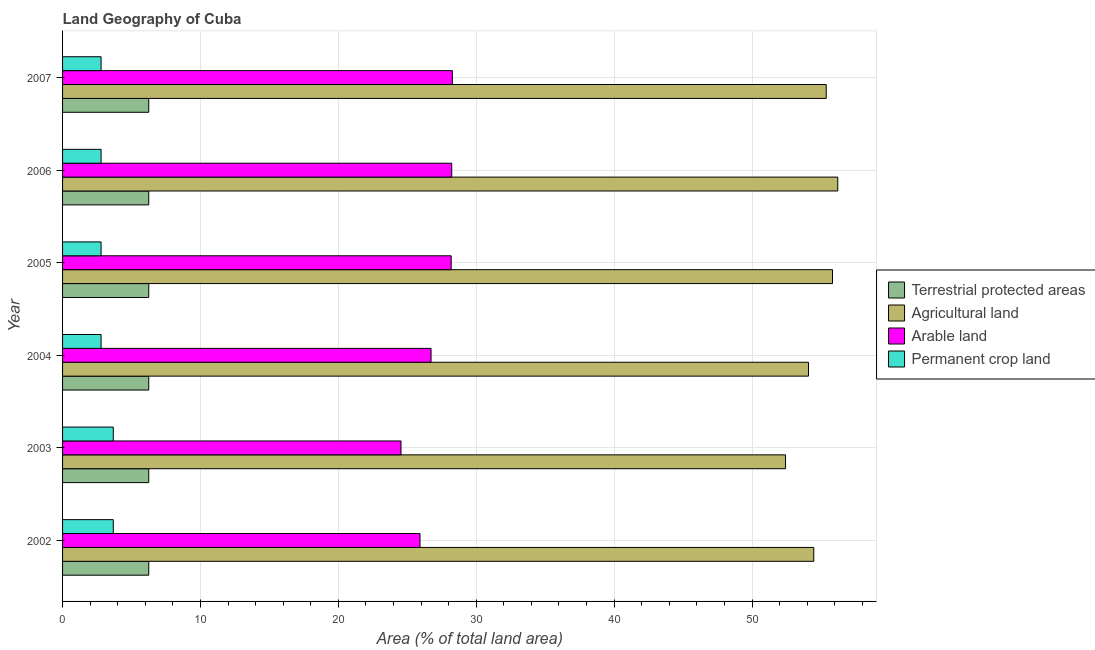How many groups of bars are there?
Offer a very short reply. 6. Are the number of bars per tick equal to the number of legend labels?
Keep it short and to the point. Yes. How many bars are there on the 3rd tick from the bottom?
Your answer should be very brief. 4. What is the label of the 6th group of bars from the top?
Give a very brief answer. 2002. What is the percentage of area under permanent crop land in 2003?
Provide a succinct answer. 3.68. Across all years, what is the maximum percentage of area under agricultural land?
Give a very brief answer. 56.22. Across all years, what is the minimum percentage of land under terrestrial protection?
Keep it short and to the point. 6.25. What is the total percentage of land under terrestrial protection in the graph?
Your response must be concise. 37.5. What is the difference between the percentage of land under terrestrial protection in 2004 and the percentage of area under permanent crop land in 2005?
Your response must be concise. 3.46. What is the average percentage of area under agricultural land per year?
Offer a terse response. 54.74. In the year 2006, what is the difference between the percentage of area under arable land and percentage of area under agricultural land?
Offer a terse response. -28. In how many years, is the percentage of area under agricultural land greater than 54 %?
Ensure brevity in your answer.  5. Is the difference between the percentage of land under terrestrial protection in 2002 and 2004 greater than the difference between the percentage of area under agricultural land in 2002 and 2004?
Your answer should be compact. No. What is the difference between the highest and the second highest percentage of area under permanent crop land?
Offer a terse response. 0. What is the difference between the highest and the lowest percentage of area under agricultural land?
Ensure brevity in your answer.  3.79. Is the sum of the percentage of area under agricultural land in 2002 and 2004 greater than the maximum percentage of land under terrestrial protection across all years?
Offer a very short reply. Yes. Is it the case that in every year, the sum of the percentage of area under permanent crop land and percentage of area under arable land is greater than the sum of percentage of area under agricultural land and percentage of land under terrestrial protection?
Provide a succinct answer. No. What does the 1st bar from the top in 2002 represents?
Your answer should be compact. Permanent crop land. What does the 1st bar from the bottom in 2004 represents?
Make the answer very short. Terrestrial protected areas. Is it the case that in every year, the sum of the percentage of land under terrestrial protection and percentage of area under agricultural land is greater than the percentage of area under arable land?
Give a very brief answer. Yes. Are the values on the major ticks of X-axis written in scientific E-notation?
Make the answer very short. No. Where does the legend appear in the graph?
Your response must be concise. Center right. What is the title of the graph?
Offer a terse response. Land Geography of Cuba. What is the label or title of the X-axis?
Provide a succinct answer. Area (% of total land area). What is the label or title of the Y-axis?
Offer a terse response. Year. What is the Area (% of total land area) of Terrestrial protected areas in 2002?
Provide a short and direct response. 6.25. What is the Area (% of total land area) of Agricultural land in 2002?
Ensure brevity in your answer.  54.48. What is the Area (% of total land area) in Arable land in 2002?
Provide a short and direct response. 25.92. What is the Area (% of total land area) of Permanent crop land in 2002?
Make the answer very short. 3.68. What is the Area (% of total land area) of Terrestrial protected areas in 2003?
Give a very brief answer. 6.25. What is the Area (% of total land area) in Agricultural land in 2003?
Provide a short and direct response. 52.43. What is the Area (% of total land area) in Arable land in 2003?
Give a very brief answer. 24.54. What is the Area (% of total land area) in Permanent crop land in 2003?
Make the answer very short. 3.68. What is the Area (% of total land area) of Terrestrial protected areas in 2004?
Provide a succinct answer. 6.25. What is the Area (% of total land area) in Agricultural land in 2004?
Your answer should be compact. 54.1. What is the Area (% of total land area) in Arable land in 2004?
Give a very brief answer. 26.72. What is the Area (% of total land area) of Permanent crop land in 2004?
Your answer should be compact. 2.79. What is the Area (% of total land area) of Terrestrial protected areas in 2005?
Provide a succinct answer. 6.25. What is the Area (% of total land area) of Agricultural land in 2005?
Ensure brevity in your answer.  55.84. What is the Area (% of total land area) of Arable land in 2005?
Give a very brief answer. 28.18. What is the Area (% of total land area) in Permanent crop land in 2005?
Keep it short and to the point. 2.79. What is the Area (% of total land area) in Terrestrial protected areas in 2006?
Keep it short and to the point. 6.25. What is the Area (% of total land area) in Agricultural land in 2006?
Ensure brevity in your answer.  56.22. What is the Area (% of total land area) of Arable land in 2006?
Offer a very short reply. 28.22. What is the Area (% of total land area) of Permanent crop land in 2006?
Offer a very short reply. 2.79. What is the Area (% of total land area) of Terrestrial protected areas in 2007?
Your answer should be very brief. 6.25. What is the Area (% of total land area) in Agricultural land in 2007?
Provide a short and direct response. 55.38. What is the Area (% of total land area) of Arable land in 2007?
Keep it short and to the point. 28.27. What is the Area (% of total land area) of Permanent crop land in 2007?
Offer a terse response. 2.79. Across all years, what is the maximum Area (% of total land area) in Terrestrial protected areas?
Offer a very short reply. 6.25. Across all years, what is the maximum Area (% of total land area) in Agricultural land?
Offer a terse response. 56.22. Across all years, what is the maximum Area (% of total land area) in Arable land?
Keep it short and to the point. 28.27. Across all years, what is the maximum Area (% of total land area) in Permanent crop land?
Offer a terse response. 3.68. Across all years, what is the minimum Area (% of total land area) in Terrestrial protected areas?
Offer a very short reply. 6.25. Across all years, what is the minimum Area (% of total land area) in Agricultural land?
Give a very brief answer. 52.43. Across all years, what is the minimum Area (% of total land area) in Arable land?
Your answer should be compact. 24.54. Across all years, what is the minimum Area (% of total land area) of Permanent crop land?
Offer a very short reply. 2.79. What is the total Area (% of total land area) in Terrestrial protected areas in the graph?
Ensure brevity in your answer.  37.5. What is the total Area (% of total land area) in Agricultural land in the graph?
Make the answer very short. 328.45. What is the total Area (% of total land area) in Arable land in the graph?
Offer a very short reply. 161.86. What is the total Area (% of total land area) of Permanent crop land in the graph?
Keep it short and to the point. 18.53. What is the difference between the Area (% of total land area) of Agricultural land in 2002 and that in 2003?
Provide a short and direct response. 2.05. What is the difference between the Area (% of total land area) of Arable land in 2002 and that in 2003?
Your answer should be compact. 1.38. What is the difference between the Area (% of total land area) in Permanent crop land in 2002 and that in 2003?
Provide a succinct answer. 0. What is the difference between the Area (% of total land area) in Agricultural land in 2002 and that in 2004?
Provide a short and direct response. 0.38. What is the difference between the Area (% of total land area) in Arable land in 2002 and that in 2004?
Keep it short and to the point. -0.8. What is the difference between the Area (% of total land area) in Permanent crop land in 2002 and that in 2004?
Make the answer very short. 0.88. What is the difference between the Area (% of total land area) in Terrestrial protected areas in 2002 and that in 2005?
Your answer should be very brief. 0. What is the difference between the Area (% of total land area) of Agricultural land in 2002 and that in 2005?
Your answer should be very brief. -1.36. What is the difference between the Area (% of total land area) of Arable land in 2002 and that in 2005?
Provide a succinct answer. -2.26. What is the difference between the Area (% of total land area) of Permanent crop land in 2002 and that in 2005?
Provide a succinct answer. 0.88. What is the difference between the Area (% of total land area) in Terrestrial protected areas in 2002 and that in 2006?
Keep it short and to the point. 0. What is the difference between the Area (% of total land area) in Agricultural land in 2002 and that in 2006?
Your answer should be compact. -1.74. What is the difference between the Area (% of total land area) of Arable land in 2002 and that in 2006?
Provide a short and direct response. -2.3. What is the difference between the Area (% of total land area) in Permanent crop land in 2002 and that in 2006?
Your answer should be very brief. 0.88. What is the difference between the Area (% of total land area) in Agricultural land in 2002 and that in 2007?
Give a very brief answer. -0.9. What is the difference between the Area (% of total land area) in Arable land in 2002 and that in 2007?
Give a very brief answer. -2.35. What is the difference between the Area (% of total land area) in Permanent crop land in 2002 and that in 2007?
Give a very brief answer. 0.88. What is the difference between the Area (% of total land area) in Agricultural land in 2003 and that in 2004?
Offer a very short reply. -1.67. What is the difference between the Area (% of total land area) in Arable land in 2003 and that in 2004?
Give a very brief answer. -2.18. What is the difference between the Area (% of total land area) of Permanent crop land in 2003 and that in 2004?
Your answer should be compact. 0.88. What is the difference between the Area (% of total land area) of Agricultural land in 2003 and that in 2005?
Offer a very short reply. -3.41. What is the difference between the Area (% of total land area) of Arable land in 2003 and that in 2005?
Keep it short and to the point. -3.64. What is the difference between the Area (% of total land area) in Permanent crop land in 2003 and that in 2005?
Offer a terse response. 0.88. What is the difference between the Area (% of total land area) of Terrestrial protected areas in 2003 and that in 2006?
Provide a short and direct response. 0. What is the difference between the Area (% of total land area) in Agricultural land in 2003 and that in 2006?
Ensure brevity in your answer.  -3.79. What is the difference between the Area (% of total land area) in Arable land in 2003 and that in 2006?
Your answer should be compact. -3.68. What is the difference between the Area (% of total land area) of Permanent crop land in 2003 and that in 2006?
Give a very brief answer. 0.88. What is the difference between the Area (% of total land area) in Terrestrial protected areas in 2003 and that in 2007?
Ensure brevity in your answer.  0. What is the difference between the Area (% of total land area) of Agricultural land in 2003 and that in 2007?
Ensure brevity in your answer.  -2.95. What is the difference between the Area (% of total land area) in Arable land in 2003 and that in 2007?
Offer a very short reply. -3.72. What is the difference between the Area (% of total land area) of Permanent crop land in 2003 and that in 2007?
Offer a very short reply. 0.88. What is the difference between the Area (% of total land area) of Agricultural land in 2004 and that in 2005?
Offer a terse response. -1.74. What is the difference between the Area (% of total land area) of Arable land in 2004 and that in 2005?
Give a very brief answer. -1.46. What is the difference between the Area (% of total land area) of Terrestrial protected areas in 2004 and that in 2006?
Your response must be concise. 0. What is the difference between the Area (% of total land area) in Agricultural land in 2004 and that in 2006?
Your answer should be compact. -2.12. What is the difference between the Area (% of total land area) of Arable land in 2004 and that in 2006?
Your answer should be very brief. -1.5. What is the difference between the Area (% of total land area) in Permanent crop land in 2004 and that in 2006?
Provide a short and direct response. 0. What is the difference between the Area (% of total land area) of Agricultural land in 2004 and that in 2007?
Provide a succinct answer. -1.28. What is the difference between the Area (% of total land area) in Arable land in 2004 and that in 2007?
Offer a terse response. -1.55. What is the difference between the Area (% of total land area) in Permanent crop land in 2004 and that in 2007?
Give a very brief answer. 0. What is the difference between the Area (% of total land area) of Agricultural land in 2005 and that in 2006?
Offer a terse response. -0.38. What is the difference between the Area (% of total land area) of Arable land in 2005 and that in 2006?
Offer a terse response. -0.04. What is the difference between the Area (% of total land area) of Permanent crop land in 2005 and that in 2006?
Provide a short and direct response. 0. What is the difference between the Area (% of total land area) in Agricultural land in 2005 and that in 2007?
Offer a terse response. 0.46. What is the difference between the Area (% of total land area) of Arable land in 2005 and that in 2007?
Make the answer very short. -0.08. What is the difference between the Area (% of total land area) in Permanent crop land in 2005 and that in 2007?
Offer a terse response. 0. What is the difference between the Area (% of total land area) in Agricultural land in 2006 and that in 2007?
Make the answer very short. 0.84. What is the difference between the Area (% of total land area) of Arable land in 2006 and that in 2007?
Your answer should be compact. -0.05. What is the difference between the Area (% of total land area) of Terrestrial protected areas in 2002 and the Area (% of total land area) of Agricultural land in 2003?
Your response must be concise. -46.18. What is the difference between the Area (% of total land area) in Terrestrial protected areas in 2002 and the Area (% of total land area) in Arable land in 2003?
Provide a succinct answer. -18.29. What is the difference between the Area (% of total land area) in Terrestrial protected areas in 2002 and the Area (% of total land area) in Permanent crop land in 2003?
Provide a short and direct response. 2.57. What is the difference between the Area (% of total land area) of Agricultural land in 2002 and the Area (% of total land area) of Arable land in 2003?
Provide a succinct answer. 29.93. What is the difference between the Area (% of total land area) of Agricultural land in 2002 and the Area (% of total land area) of Permanent crop land in 2003?
Give a very brief answer. 50.8. What is the difference between the Area (% of total land area) of Arable land in 2002 and the Area (% of total land area) of Permanent crop land in 2003?
Offer a very short reply. 22.24. What is the difference between the Area (% of total land area) in Terrestrial protected areas in 2002 and the Area (% of total land area) in Agricultural land in 2004?
Make the answer very short. -47.85. What is the difference between the Area (% of total land area) of Terrestrial protected areas in 2002 and the Area (% of total land area) of Arable land in 2004?
Provide a short and direct response. -20.47. What is the difference between the Area (% of total land area) of Terrestrial protected areas in 2002 and the Area (% of total land area) of Permanent crop land in 2004?
Offer a terse response. 3.46. What is the difference between the Area (% of total land area) of Agricultural land in 2002 and the Area (% of total land area) of Arable land in 2004?
Offer a terse response. 27.76. What is the difference between the Area (% of total land area) in Agricultural land in 2002 and the Area (% of total land area) in Permanent crop land in 2004?
Make the answer very short. 51.69. What is the difference between the Area (% of total land area) in Arable land in 2002 and the Area (% of total land area) in Permanent crop land in 2004?
Offer a very short reply. 23.13. What is the difference between the Area (% of total land area) of Terrestrial protected areas in 2002 and the Area (% of total land area) of Agricultural land in 2005?
Provide a short and direct response. -49.59. What is the difference between the Area (% of total land area) in Terrestrial protected areas in 2002 and the Area (% of total land area) in Arable land in 2005?
Provide a short and direct response. -21.93. What is the difference between the Area (% of total land area) of Terrestrial protected areas in 2002 and the Area (% of total land area) of Permanent crop land in 2005?
Provide a short and direct response. 3.46. What is the difference between the Area (% of total land area) in Agricultural land in 2002 and the Area (% of total land area) in Arable land in 2005?
Give a very brief answer. 26.29. What is the difference between the Area (% of total land area) of Agricultural land in 2002 and the Area (% of total land area) of Permanent crop land in 2005?
Offer a terse response. 51.69. What is the difference between the Area (% of total land area) of Arable land in 2002 and the Area (% of total land area) of Permanent crop land in 2005?
Offer a terse response. 23.13. What is the difference between the Area (% of total land area) of Terrestrial protected areas in 2002 and the Area (% of total land area) of Agricultural land in 2006?
Give a very brief answer. -49.97. What is the difference between the Area (% of total land area) of Terrestrial protected areas in 2002 and the Area (% of total land area) of Arable land in 2006?
Your response must be concise. -21.97. What is the difference between the Area (% of total land area) in Terrestrial protected areas in 2002 and the Area (% of total land area) in Permanent crop land in 2006?
Your response must be concise. 3.46. What is the difference between the Area (% of total land area) in Agricultural land in 2002 and the Area (% of total land area) in Arable land in 2006?
Your response must be concise. 26.26. What is the difference between the Area (% of total land area) of Agricultural land in 2002 and the Area (% of total land area) of Permanent crop land in 2006?
Provide a succinct answer. 51.69. What is the difference between the Area (% of total land area) in Arable land in 2002 and the Area (% of total land area) in Permanent crop land in 2006?
Offer a terse response. 23.13. What is the difference between the Area (% of total land area) of Terrestrial protected areas in 2002 and the Area (% of total land area) of Agricultural land in 2007?
Offer a terse response. -49.13. What is the difference between the Area (% of total land area) in Terrestrial protected areas in 2002 and the Area (% of total land area) in Arable land in 2007?
Your answer should be compact. -22.02. What is the difference between the Area (% of total land area) of Terrestrial protected areas in 2002 and the Area (% of total land area) of Permanent crop land in 2007?
Offer a very short reply. 3.46. What is the difference between the Area (% of total land area) in Agricultural land in 2002 and the Area (% of total land area) in Arable land in 2007?
Your response must be concise. 26.21. What is the difference between the Area (% of total land area) in Agricultural land in 2002 and the Area (% of total land area) in Permanent crop land in 2007?
Offer a very short reply. 51.69. What is the difference between the Area (% of total land area) in Arable land in 2002 and the Area (% of total land area) in Permanent crop land in 2007?
Ensure brevity in your answer.  23.13. What is the difference between the Area (% of total land area) in Terrestrial protected areas in 2003 and the Area (% of total land area) in Agricultural land in 2004?
Give a very brief answer. -47.85. What is the difference between the Area (% of total land area) of Terrestrial protected areas in 2003 and the Area (% of total land area) of Arable land in 2004?
Give a very brief answer. -20.47. What is the difference between the Area (% of total land area) in Terrestrial protected areas in 2003 and the Area (% of total land area) in Permanent crop land in 2004?
Make the answer very short. 3.46. What is the difference between the Area (% of total land area) of Agricultural land in 2003 and the Area (% of total land area) of Arable land in 2004?
Offer a very short reply. 25.71. What is the difference between the Area (% of total land area) in Agricultural land in 2003 and the Area (% of total land area) in Permanent crop land in 2004?
Your response must be concise. 49.64. What is the difference between the Area (% of total land area) of Arable land in 2003 and the Area (% of total land area) of Permanent crop land in 2004?
Provide a succinct answer. 21.75. What is the difference between the Area (% of total land area) of Terrestrial protected areas in 2003 and the Area (% of total land area) of Agricultural land in 2005?
Offer a very short reply. -49.59. What is the difference between the Area (% of total land area) in Terrestrial protected areas in 2003 and the Area (% of total land area) in Arable land in 2005?
Make the answer very short. -21.93. What is the difference between the Area (% of total land area) in Terrestrial protected areas in 2003 and the Area (% of total land area) in Permanent crop land in 2005?
Your answer should be compact. 3.46. What is the difference between the Area (% of total land area) in Agricultural land in 2003 and the Area (% of total land area) in Arable land in 2005?
Give a very brief answer. 24.25. What is the difference between the Area (% of total land area) of Agricultural land in 2003 and the Area (% of total land area) of Permanent crop land in 2005?
Your answer should be very brief. 49.64. What is the difference between the Area (% of total land area) of Arable land in 2003 and the Area (% of total land area) of Permanent crop land in 2005?
Your response must be concise. 21.75. What is the difference between the Area (% of total land area) in Terrestrial protected areas in 2003 and the Area (% of total land area) in Agricultural land in 2006?
Offer a terse response. -49.97. What is the difference between the Area (% of total land area) of Terrestrial protected areas in 2003 and the Area (% of total land area) of Arable land in 2006?
Provide a succinct answer. -21.97. What is the difference between the Area (% of total land area) of Terrestrial protected areas in 2003 and the Area (% of total land area) of Permanent crop land in 2006?
Your answer should be compact. 3.46. What is the difference between the Area (% of total land area) in Agricultural land in 2003 and the Area (% of total land area) in Arable land in 2006?
Provide a succinct answer. 24.21. What is the difference between the Area (% of total land area) of Agricultural land in 2003 and the Area (% of total land area) of Permanent crop land in 2006?
Offer a terse response. 49.64. What is the difference between the Area (% of total land area) of Arable land in 2003 and the Area (% of total land area) of Permanent crop land in 2006?
Provide a short and direct response. 21.75. What is the difference between the Area (% of total land area) in Terrestrial protected areas in 2003 and the Area (% of total land area) in Agricultural land in 2007?
Keep it short and to the point. -49.13. What is the difference between the Area (% of total land area) in Terrestrial protected areas in 2003 and the Area (% of total land area) in Arable land in 2007?
Provide a succinct answer. -22.02. What is the difference between the Area (% of total land area) of Terrestrial protected areas in 2003 and the Area (% of total land area) of Permanent crop land in 2007?
Your response must be concise. 3.46. What is the difference between the Area (% of total land area) of Agricultural land in 2003 and the Area (% of total land area) of Arable land in 2007?
Ensure brevity in your answer.  24.16. What is the difference between the Area (% of total land area) in Agricultural land in 2003 and the Area (% of total land area) in Permanent crop land in 2007?
Your answer should be very brief. 49.64. What is the difference between the Area (% of total land area) in Arable land in 2003 and the Area (% of total land area) in Permanent crop land in 2007?
Give a very brief answer. 21.75. What is the difference between the Area (% of total land area) of Terrestrial protected areas in 2004 and the Area (% of total land area) of Agricultural land in 2005?
Your answer should be compact. -49.59. What is the difference between the Area (% of total land area) in Terrestrial protected areas in 2004 and the Area (% of total land area) in Arable land in 2005?
Give a very brief answer. -21.93. What is the difference between the Area (% of total land area) in Terrestrial protected areas in 2004 and the Area (% of total land area) in Permanent crop land in 2005?
Your response must be concise. 3.46. What is the difference between the Area (% of total land area) in Agricultural land in 2004 and the Area (% of total land area) in Arable land in 2005?
Offer a terse response. 25.91. What is the difference between the Area (% of total land area) of Agricultural land in 2004 and the Area (% of total land area) of Permanent crop land in 2005?
Provide a short and direct response. 51.3. What is the difference between the Area (% of total land area) of Arable land in 2004 and the Area (% of total land area) of Permanent crop land in 2005?
Keep it short and to the point. 23.93. What is the difference between the Area (% of total land area) in Terrestrial protected areas in 2004 and the Area (% of total land area) in Agricultural land in 2006?
Your answer should be compact. -49.97. What is the difference between the Area (% of total land area) in Terrestrial protected areas in 2004 and the Area (% of total land area) in Arable land in 2006?
Your answer should be compact. -21.97. What is the difference between the Area (% of total land area) of Terrestrial protected areas in 2004 and the Area (% of total land area) of Permanent crop land in 2006?
Give a very brief answer. 3.46. What is the difference between the Area (% of total land area) in Agricultural land in 2004 and the Area (% of total land area) in Arable land in 2006?
Make the answer very short. 25.88. What is the difference between the Area (% of total land area) of Agricultural land in 2004 and the Area (% of total land area) of Permanent crop land in 2006?
Your answer should be very brief. 51.3. What is the difference between the Area (% of total land area) in Arable land in 2004 and the Area (% of total land area) in Permanent crop land in 2006?
Offer a very short reply. 23.93. What is the difference between the Area (% of total land area) of Terrestrial protected areas in 2004 and the Area (% of total land area) of Agricultural land in 2007?
Your answer should be compact. -49.13. What is the difference between the Area (% of total land area) of Terrestrial protected areas in 2004 and the Area (% of total land area) of Arable land in 2007?
Provide a short and direct response. -22.02. What is the difference between the Area (% of total land area) of Terrestrial protected areas in 2004 and the Area (% of total land area) of Permanent crop land in 2007?
Your answer should be very brief. 3.46. What is the difference between the Area (% of total land area) of Agricultural land in 2004 and the Area (% of total land area) of Arable land in 2007?
Offer a terse response. 25.83. What is the difference between the Area (% of total land area) of Agricultural land in 2004 and the Area (% of total land area) of Permanent crop land in 2007?
Provide a short and direct response. 51.3. What is the difference between the Area (% of total land area) in Arable land in 2004 and the Area (% of total land area) in Permanent crop land in 2007?
Your answer should be compact. 23.93. What is the difference between the Area (% of total land area) in Terrestrial protected areas in 2005 and the Area (% of total land area) in Agricultural land in 2006?
Make the answer very short. -49.97. What is the difference between the Area (% of total land area) in Terrestrial protected areas in 2005 and the Area (% of total land area) in Arable land in 2006?
Your answer should be compact. -21.97. What is the difference between the Area (% of total land area) in Terrestrial protected areas in 2005 and the Area (% of total land area) in Permanent crop land in 2006?
Offer a terse response. 3.46. What is the difference between the Area (% of total land area) in Agricultural land in 2005 and the Area (% of total land area) in Arable land in 2006?
Make the answer very short. 27.62. What is the difference between the Area (% of total land area) of Agricultural land in 2005 and the Area (% of total land area) of Permanent crop land in 2006?
Offer a very short reply. 53.04. What is the difference between the Area (% of total land area) of Arable land in 2005 and the Area (% of total land area) of Permanent crop land in 2006?
Your response must be concise. 25.39. What is the difference between the Area (% of total land area) in Terrestrial protected areas in 2005 and the Area (% of total land area) in Agricultural land in 2007?
Make the answer very short. -49.13. What is the difference between the Area (% of total land area) in Terrestrial protected areas in 2005 and the Area (% of total land area) in Arable land in 2007?
Your answer should be compact. -22.02. What is the difference between the Area (% of total land area) in Terrestrial protected areas in 2005 and the Area (% of total land area) in Permanent crop land in 2007?
Provide a succinct answer. 3.46. What is the difference between the Area (% of total land area) of Agricultural land in 2005 and the Area (% of total land area) of Arable land in 2007?
Offer a very short reply. 27.57. What is the difference between the Area (% of total land area) in Agricultural land in 2005 and the Area (% of total land area) in Permanent crop land in 2007?
Offer a very short reply. 53.04. What is the difference between the Area (% of total land area) in Arable land in 2005 and the Area (% of total land area) in Permanent crop land in 2007?
Your answer should be very brief. 25.39. What is the difference between the Area (% of total land area) in Terrestrial protected areas in 2006 and the Area (% of total land area) in Agricultural land in 2007?
Offer a very short reply. -49.13. What is the difference between the Area (% of total land area) in Terrestrial protected areas in 2006 and the Area (% of total land area) in Arable land in 2007?
Ensure brevity in your answer.  -22.02. What is the difference between the Area (% of total land area) in Terrestrial protected areas in 2006 and the Area (% of total land area) in Permanent crop land in 2007?
Provide a short and direct response. 3.46. What is the difference between the Area (% of total land area) in Agricultural land in 2006 and the Area (% of total land area) in Arable land in 2007?
Offer a very short reply. 27.95. What is the difference between the Area (% of total land area) of Agricultural land in 2006 and the Area (% of total land area) of Permanent crop land in 2007?
Your answer should be compact. 53.43. What is the difference between the Area (% of total land area) of Arable land in 2006 and the Area (% of total land area) of Permanent crop land in 2007?
Ensure brevity in your answer.  25.43. What is the average Area (% of total land area) in Terrestrial protected areas per year?
Give a very brief answer. 6.25. What is the average Area (% of total land area) of Agricultural land per year?
Provide a short and direct response. 54.74. What is the average Area (% of total land area) in Arable land per year?
Ensure brevity in your answer.  26.98. What is the average Area (% of total land area) in Permanent crop land per year?
Ensure brevity in your answer.  3.09. In the year 2002, what is the difference between the Area (% of total land area) of Terrestrial protected areas and Area (% of total land area) of Agricultural land?
Provide a succinct answer. -48.23. In the year 2002, what is the difference between the Area (% of total land area) in Terrestrial protected areas and Area (% of total land area) in Arable land?
Make the answer very short. -19.67. In the year 2002, what is the difference between the Area (% of total land area) in Terrestrial protected areas and Area (% of total land area) in Permanent crop land?
Make the answer very short. 2.57. In the year 2002, what is the difference between the Area (% of total land area) in Agricultural land and Area (% of total land area) in Arable land?
Ensure brevity in your answer.  28.56. In the year 2002, what is the difference between the Area (% of total land area) of Agricultural land and Area (% of total land area) of Permanent crop land?
Ensure brevity in your answer.  50.8. In the year 2002, what is the difference between the Area (% of total land area) of Arable land and Area (% of total land area) of Permanent crop land?
Offer a terse response. 22.24. In the year 2003, what is the difference between the Area (% of total land area) of Terrestrial protected areas and Area (% of total land area) of Agricultural land?
Keep it short and to the point. -46.18. In the year 2003, what is the difference between the Area (% of total land area) in Terrestrial protected areas and Area (% of total land area) in Arable land?
Offer a terse response. -18.29. In the year 2003, what is the difference between the Area (% of total land area) of Terrestrial protected areas and Area (% of total land area) of Permanent crop land?
Make the answer very short. 2.57. In the year 2003, what is the difference between the Area (% of total land area) of Agricultural land and Area (% of total land area) of Arable land?
Offer a very short reply. 27.89. In the year 2003, what is the difference between the Area (% of total land area) of Agricultural land and Area (% of total land area) of Permanent crop land?
Offer a terse response. 48.75. In the year 2003, what is the difference between the Area (% of total land area) of Arable land and Area (% of total land area) of Permanent crop land?
Keep it short and to the point. 20.87. In the year 2004, what is the difference between the Area (% of total land area) of Terrestrial protected areas and Area (% of total land area) of Agricultural land?
Your answer should be very brief. -47.85. In the year 2004, what is the difference between the Area (% of total land area) of Terrestrial protected areas and Area (% of total land area) of Arable land?
Ensure brevity in your answer.  -20.47. In the year 2004, what is the difference between the Area (% of total land area) of Terrestrial protected areas and Area (% of total land area) of Permanent crop land?
Offer a very short reply. 3.46. In the year 2004, what is the difference between the Area (% of total land area) in Agricultural land and Area (% of total land area) in Arable land?
Offer a terse response. 27.37. In the year 2004, what is the difference between the Area (% of total land area) of Agricultural land and Area (% of total land area) of Permanent crop land?
Make the answer very short. 51.3. In the year 2004, what is the difference between the Area (% of total land area) in Arable land and Area (% of total land area) in Permanent crop land?
Your answer should be compact. 23.93. In the year 2005, what is the difference between the Area (% of total land area) in Terrestrial protected areas and Area (% of total land area) in Agricultural land?
Give a very brief answer. -49.59. In the year 2005, what is the difference between the Area (% of total land area) of Terrestrial protected areas and Area (% of total land area) of Arable land?
Provide a succinct answer. -21.93. In the year 2005, what is the difference between the Area (% of total land area) in Terrestrial protected areas and Area (% of total land area) in Permanent crop land?
Provide a short and direct response. 3.46. In the year 2005, what is the difference between the Area (% of total land area) in Agricultural land and Area (% of total land area) in Arable land?
Offer a terse response. 27.65. In the year 2005, what is the difference between the Area (% of total land area) of Agricultural land and Area (% of total land area) of Permanent crop land?
Offer a terse response. 53.04. In the year 2005, what is the difference between the Area (% of total land area) in Arable land and Area (% of total land area) in Permanent crop land?
Offer a terse response. 25.39. In the year 2006, what is the difference between the Area (% of total land area) in Terrestrial protected areas and Area (% of total land area) in Agricultural land?
Your answer should be compact. -49.97. In the year 2006, what is the difference between the Area (% of total land area) of Terrestrial protected areas and Area (% of total land area) of Arable land?
Offer a very short reply. -21.97. In the year 2006, what is the difference between the Area (% of total land area) of Terrestrial protected areas and Area (% of total land area) of Permanent crop land?
Offer a very short reply. 3.46. In the year 2006, what is the difference between the Area (% of total land area) in Agricultural land and Area (% of total land area) in Arable land?
Provide a succinct answer. 28. In the year 2006, what is the difference between the Area (% of total land area) of Agricultural land and Area (% of total land area) of Permanent crop land?
Your answer should be compact. 53.43. In the year 2006, what is the difference between the Area (% of total land area) of Arable land and Area (% of total land area) of Permanent crop land?
Your response must be concise. 25.43. In the year 2007, what is the difference between the Area (% of total land area) of Terrestrial protected areas and Area (% of total land area) of Agricultural land?
Provide a short and direct response. -49.13. In the year 2007, what is the difference between the Area (% of total land area) in Terrestrial protected areas and Area (% of total land area) in Arable land?
Your answer should be very brief. -22.02. In the year 2007, what is the difference between the Area (% of total land area) of Terrestrial protected areas and Area (% of total land area) of Permanent crop land?
Offer a terse response. 3.46. In the year 2007, what is the difference between the Area (% of total land area) in Agricultural land and Area (% of total land area) in Arable land?
Offer a very short reply. 27.11. In the year 2007, what is the difference between the Area (% of total land area) of Agricultural land and Area (% of total land area) of Permanent crop land?
Offer a terse response. 52.59. In the year 2007, what is the difference between the Area (% of total land area) in Arable land and Area (% of total land area) in Permanent crop land?
Your response must be concise. 25.47. What is the ratio of the Area (% of total land area) in Agricultural land in 2002 to that in 2003?
Keep it short and to the point. 1.04. What is the ratio of the Area (% of total land area) in Arable land in 2002 to that in 2003?
Your answer should be compact. 1.06. What is the ratio of the Area (% of total land area) of Permanent crop land in 2002 to that in 2003?
Make the answer very short. 1. What is the ratio of the Area (% of total land area) in Terrestrial protected areas in 2002 to that in 2004?
Your answer should be very brief. 1. What is the ratio of the Area (% of total land area) of Agricultural land in 2002 to that in 2004?
Make the answer very short. 1.01. What is the ratio of the Area (% of total land area) of Arable land in 2002 to that in 2004?
Your answer should be compact. 0.97. What is the ratio of the Area (% of total land area) in Permanent crop land in 2002 to that in 2004?
Make the answer very short. 1.32. What is the ratio of the Area (% of total land area) in Terrestrial protected areas in 2002 to that in 2005?
Offer a terse response. 1. What is the ratio of the Area (% of total land area) in Agricultural land in 2002 to that in 2005?
Keep it short and to the point. 0.98. What is the ratio of the Area (% of total land area) of Arable land in 2002 to that in 2005?
Your answer should be compact. 0.92. What is the ratio of the Area (% of total land area) in Permanent crop land in 2002 to that in 2005?
Your answer should be very brief. 1.32. What is the ratio of the Area (% of total land area) of Terrestrial protected areas in 2002 to that in 2006?
Provide a succinct answer. 1. What is the ratio of the Area (% of total land area) of Agricultural land in 2002 to that in 2006?
Make the answer very short. 0.97. What is the ratio of the Area (% of total land area) of Arable land in 2002 to that in 2006?
Make the answer very short. 0.92. What is the ratio of the Area (% of total land area) of Permanent crop land in 2002 to that in 2006?
Your answer should be compact. 1.32. What is the ratio of the Area (% of total land area) in Agricultural land in 2002 to that in 2007?
Offer a terse response. 0.98. What is the ratio of the Area (% of total land area) of Arable land in 2002 to that in 2007?
Offer a terse response. 0.92. What is the ratio of the Area (% of total land area) of Permanent crop land in 2002 to that in 2007?
Make the answer very short. 1.32. What is the ratio of the Area (% of total land area) in Agricultural land in 2003 to that in 2004?
Provide a succinct answer. 0.97. What is the ratio of the Area (% of total land area) in Arable land in 2003 to that in 2004?
Your response must be concise. 0.92. What is the ratio of the Area (% of total land area) in Permanent crop land in 2003 to that in 2004?
Keep it short and to the point. 1.32. What is the ratio of the Area (% of total land area) of Terrestrial protected areas in 2003 to that in 2005?
Your answer should be compact. 1. What is the ratio of the Area (% of total land area) in Agricultural land in 2003 to that in 2005?
Your answer should be very brief. 0.94. What is the ratio of the Area (% of total land area) of Arable land in 2003 to that in 2005?
Make the answer very short. 0.87. What is the ratio of the Area (% of total land area) of Permanent crop land in 2003 to that in 2005?
Ensure brevity in your answer.  1.32. What is the ratio of the Area (% of total land area) of Terrestrial protected areas in 2003 to that in 2006?
Make the answer very short. 1. What is the ratio of the Area (% of total land area) of Agricultural land in 2003 to that in 2006?
Your answer should be very brief. 0.93. What is the ratio of the Area (% of total land area) in Arable land in 2003 to that in 2006?
Keep it short and to the point. 0.87. What is the ratio of the Area (% of total land area) of Permanent crop land in 2003 to that in 2006?
Provide a succinct answer. 1.32. What is the ratio of the Area (% of total land area) of Terrestrial protected areas in 2003 to that in 2007?
Offer a terse response. 1. What is the ratio of the Area (% of total land area) of Agricultural land in 2003 to that in 2007?
Offer a terse response. 0.95. What is the ratio of the Area (% of total land area) of Arable land in 2003 to that in 2007?
Your answer should be compact. 0.87. What is the ratio of the Area (% of total land area) of Permanent crop land in 2003 to that in 2007?
Offer a terse response. 1.32. What is the ratio of the Area (% of total land area) of Terrestrial protected areas in 2004 to that in 2005?
Your answer should be very brief. 1. What is the ratio of the Area (% of total land area) of Agricultural land in 2004 to that in 2005?
Provide a short and direct response. 0.97. What is the ratio of the Area (% of total land area) in Arable land in 2004 to that in 2005?
Offer a terse response. 0.95. What is the ratio of the Area (% of total land area) in Permanent crop land in 2004 to that in 2005?
Your answer should be very brief. 1. What is the ratio of the Area (% of total land area) in Agricultural land in 2004 to that in 2006?
Offer a very short reply. 0.96. What is the ratio of the Area (% of total land area) of Arable land in 2004 to that in 2006?
Your answer should be very brief. 0.95. What is the ratio of the Area (% of total land area) of Permanent crop land in 2004 to that in 2006?
Your answer should be very brief. 1. What is the ratio of the Area (% of total land area) of Terrestrial protected areas in 2004 to that in 2007?
Your response must be concise. 1. What is the ratio of the Area (% of total land area) in Agricultural land in 2004 to that in 2007?
Offer a very short reply. 0.98. What is the ratio of the Area (% of total land area) of Arable land in 2004 to that in 2007?
Your answer should be compact. 0.95. What is the ratio of the Area (% of total land area) in Arable land in 2005 to that in 2006?
Your answer should be compact. 1. What is the ratio of the Area (% of total land area) in Permanent crop land in 2005 to that in 2006?
Make the answer very short. 1. What is the ratio of the Area (% of total land area) in Terrestrial protected areas in 2005 to that in 2007?
Give a very brief answer. 1. What is the ratio of the Area (% of total land area) of Agricultural land in 2005 to that in 2007?
Offer a terse response. 1.01. What is the ratio of the Area (% of total land area) of Arable land in 2005 to that in 2007?
Provide a succinct answer. 1. What is the ratio of the Area (% of total land area) of Agricultural land in 2006 to that in 2007?
Offer a terse response. 1.02. What is the difference between the highest and the second highest Area (% of total land area) of Terrestrial protected areas?
Give a very brief answer. 0. What is the difference between the highest and the second highest Area (% of total land area) of Agricultural land?
Your answer should be compact. 0.38. What is the difference between the highest and the second highest Area (% of total land area) of Arable land?
Your answer should be compact. 0.05. What is the difference between the highest and the second highest Area (% of total land area) in Permanent crop land?
Offer a very short reply. 0. What is the difference between the highest and the lowest Area (% of total land area) in Agricultural land?
Ensure brevity in your answer.  3.79. What is the difference between the highest and the lowest Area (% of total land area) in Arable land?
Offer a terse response. 3.72. What is the difference between the highest and the lowest Area (% of total land area) in Permanent crop land?
Offer a terse response. 0.88. 